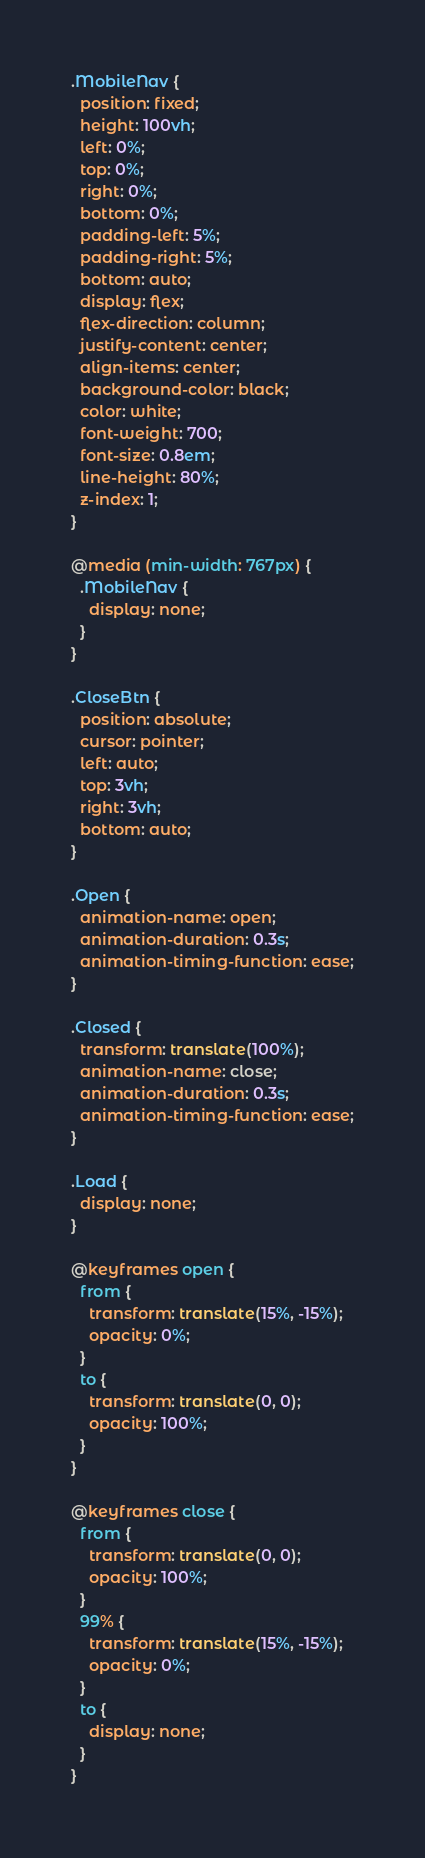<code> <loc_0><loc_0><loc_500><loc_500><_CSS_>.MobileNav {
  position: fixed;
  height: 100vh;
  left: 0%;
  top: 0%;
  right: 0%;
  bottom: 0%;
  padding-left: 5%;
  padding-right: 5%;
  bottom: auto;
  display: flex;
  flex-direction: column;
  justify-content: center;
  align-items: center;
  background-color: black;
  color: white;
  font-weight: 700;
  font-size: 0.8em;
  line-height: 80%;
  z-index: 1;
}

@media (min-width: 767px) {
  .MobileNav {
    display: none;
  }
}

.CloseBtn {
  position: absolute;
  cursor: pointer;
  left: auto;
  top: 3vh;
  right: 3vh;
  bottom: auto;
}

.Open {
  animation-name: open;
  animation-duration: 0.3s;
  animation-timing-function: ease;
}

.Closed {
  transform: translate(100%);
  animation-name: close;
  animation-duration: 0.3s;
  animation-timing-function: ease;
}

.Load {
  display: none;
}

@keyframes open {
  from {
    transform: translate(15%, -15%);
    opacity: 0%;
  }
  to {
    transform: translate(0, 0);
    opacity: 100%;
  }
}

@keyframes close {
  from {
    transform: translate(0, 0);
    opacity: 100%;
  }
  99% {
    transform: translate(15%, -15%);
    opacity: 0%;
  }
  to {
    display: none;
  }
}
</code> 